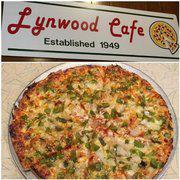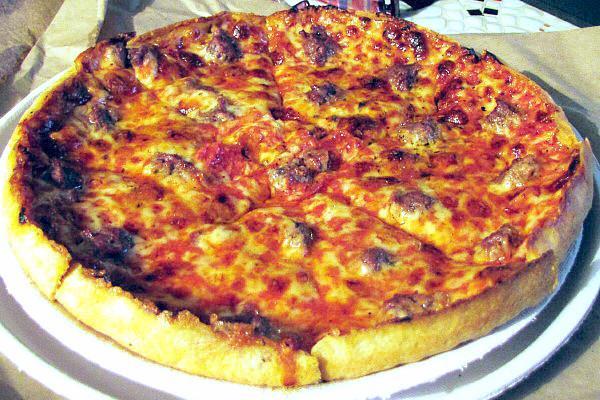The first image is the image on the left, the second image is the image on the right. For the images displayed, is the sentence "All of the pizzas are whole without any pieces missing." factually correct? Answer yes or no. Yes. The first image is the image on the left, the second image is the image on the right. Evaluate the accuracy of this statement regarding the images: "The left image shows a round sliced pizza in a round pan with an empty space where two slices would fit, and does not show any other pans of pizza.". Is it true? Answer yes or no. No. 